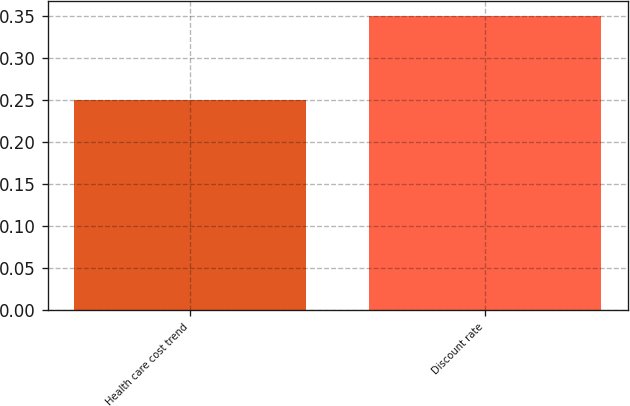Convert chart. <chart><loc_0><loc_0><loc_500><loc_500><bar_chart><fcel>Health care cost trend<fcel>Discount rate<nl><fcel>0.25<fcel>0.35<nl></chart> 